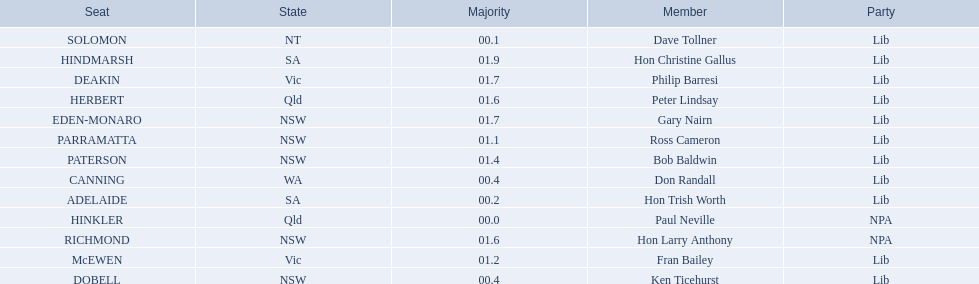Who are all the lib party members? Dave Tollner, Hon Trish Worth, Don Randall, Ken Ticehurst, Ross Cameron, Fran Bailey, Bob Baldwin, Peter Lindsay, Philip Barresi, Gary Nairn, Hon Christine Gallus. What lib party members are in sa? Hon Trish Worth, Hon Christine Gallus. What is the highest difference in majority between members in sa? 01.9. 